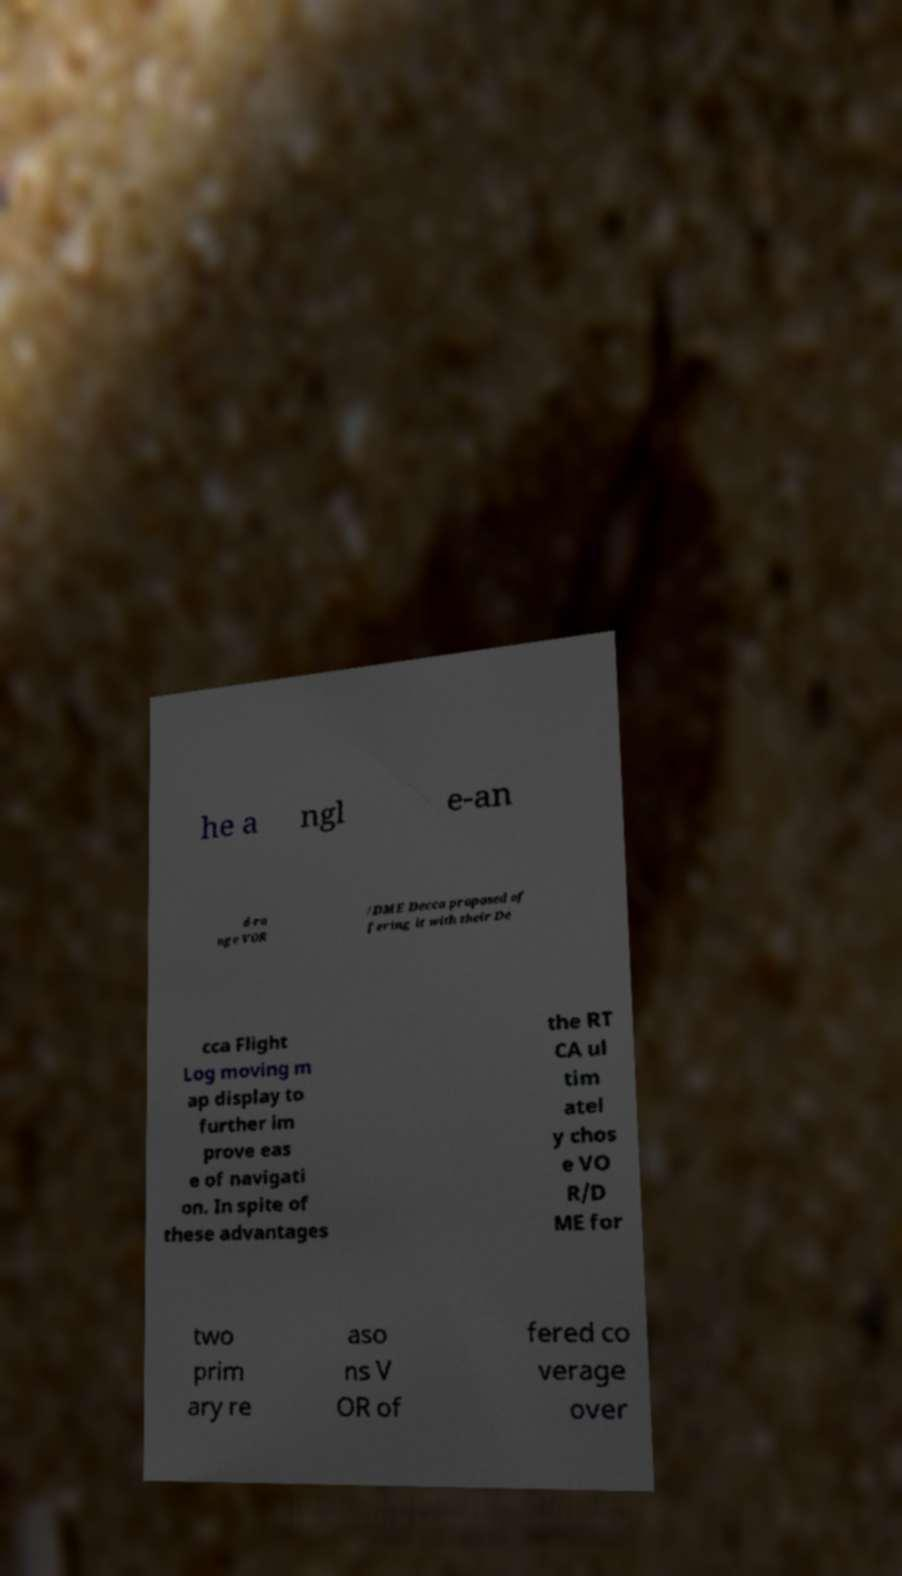Please read and relay the text visible in this image. What does it say? he a ngl e-an d-ra nge VOR /DME Decca proposed of fering it with their De cca Flight Log moving m ap display to further im prove eas e of navigati on. In spite of these advantages the RT CA ul tim atel y chos e VO R/D ME for two prim ary re aso ns V OR of fered co verage over 